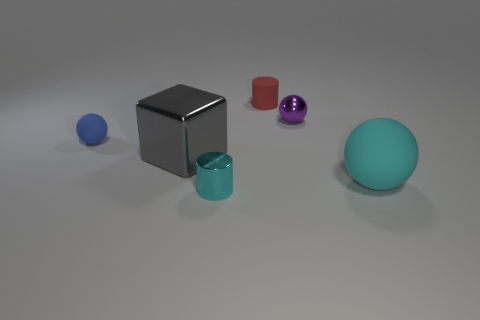What is the size of the metallic object on the left side of the metal thing that is in front of the large metal cube that is on the left side of the cyan metal cylinder?
Your response must be concise. Large. There is a metal ball; are there any big gray blocks right of it?
Give a very brief answer. No. There is another blue sphere that is made of the same material as the big ball; what is its size?
Give a very brief answer. Small. How many other rubber objects have the same shape as the small purple object?
Your response must be concise. 2. Does the large gray object have the same material as the cyan thing that is left of the big cyan sphere?
Keep it short and to the point. Yes. Is the number of cyan spheres that are right of the small cyan metallic cylinder greater than the number of cubes?
Make the answer very short. No. What shape is the tiny thing that is the same color as the big matte object?
Ensure brevity in your answer.  Cylinder. Are there any purple things made of the same material as the red cylinder?
Provide a succinct answer. No. Are the cyan object that is behind the cyan metal cylinder and the tiny sphere that is on the right side of the cyan cylinder made of the same material?
Give a very brief answer. No. Are there an equal number of small blue rubber balls that are behind the large metal thing and gray cubes that are in front of the tiny cyan metallic thing?
Your answer should be very brief. No. 